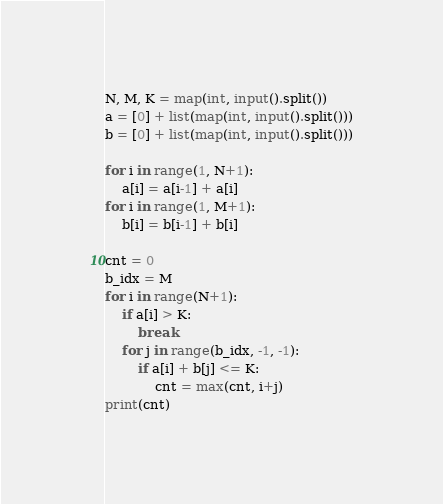Convert code to text. <code><loc_0><loc_0><loc_500><loc_500><_Python_>N, M, K = map(int, input().split())
a = [0] + list(map(int, input().split()))
b = [0] + list(map(int, input().split()))

for i in range(1, N+1):
    a[i] = a[i-1] + a[i]
for i in range(1, M+1):
    b[i] = b[i-1] + b[i]

cnt = 0
b_idx = M
for i in range(N+1):
    if a[i] > K:
        break
    for j in range(b_idx, -1, -1):
        if a[i] + b[j] <= K:
            cnt = max(cnt, i+j)
print(cnt)</code> 